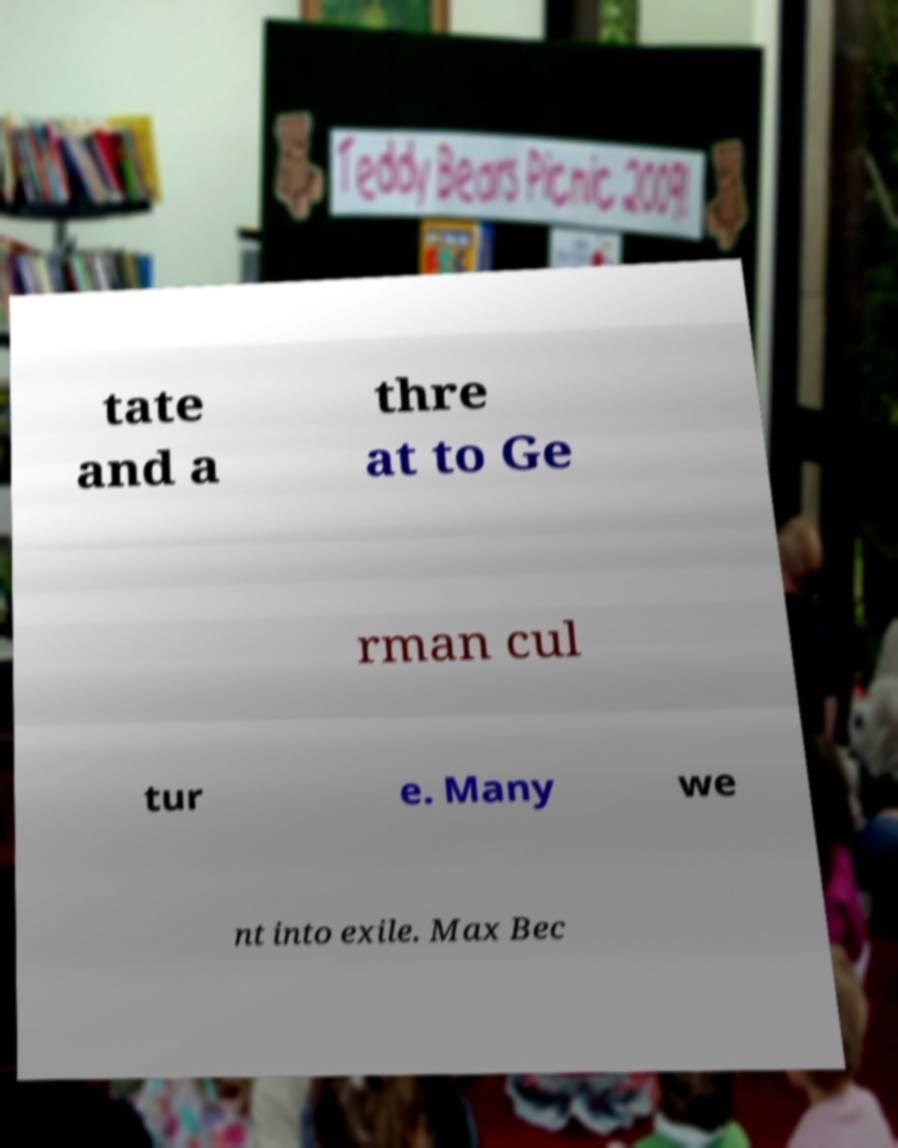Please identify and transcribe the text found in this image. tate and a thre at to Ge rman cul tur e. Many we nt into exile. Max Bec 